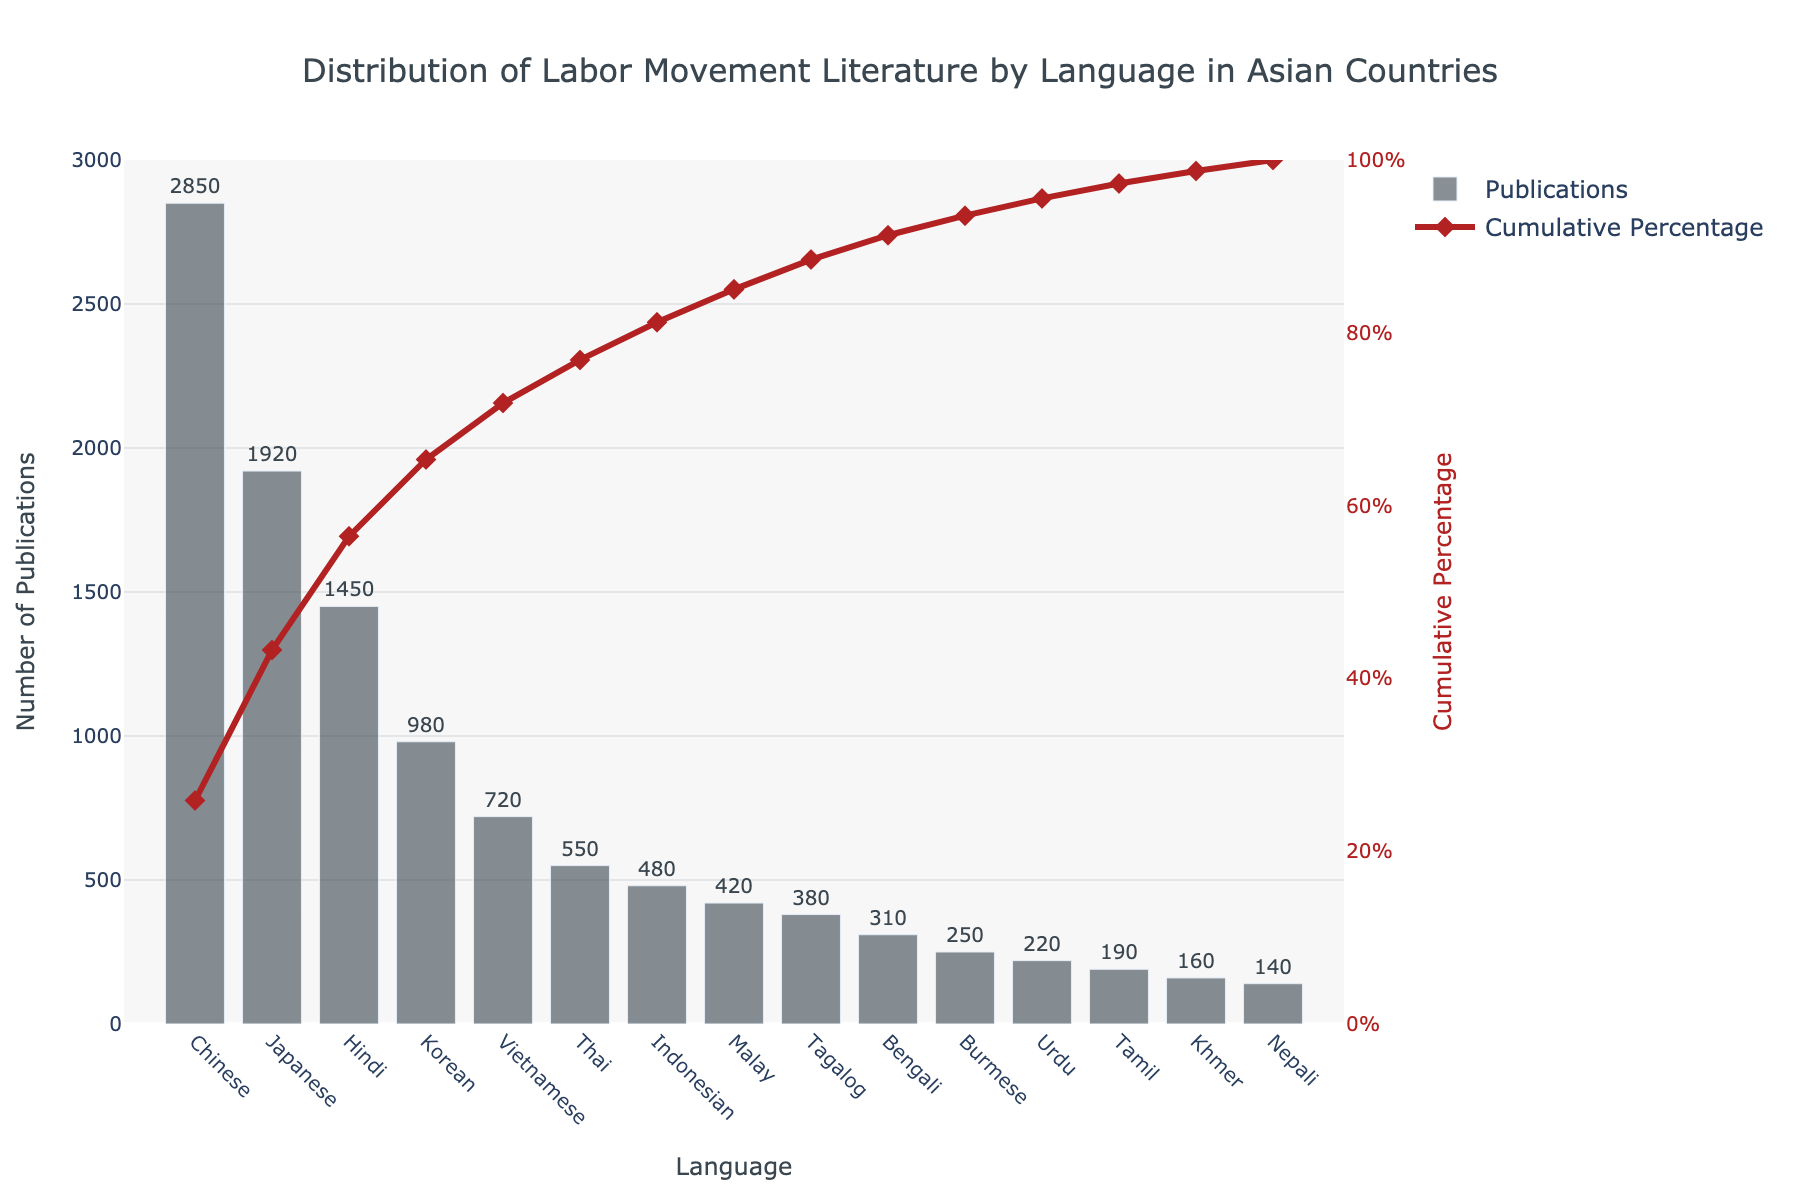What is the language with the highest number of publications? The language with the highest number of publications can be found by looking at the tallest bar in the bar chart. The tallest bar is labeled "Chinese."
Answer: Chinese What percentage of total publications do Chinese and Japanese combined contribute to? First, find the number of publications for Chinese (2850) and Japanese (1920) and add them together (2850 + 1920 = 4770). Then, find the total number of publications of all languages and divide the sum by this total. Finally, multiply by 100 to convert it to a percentage.
Answer: 48.6% Which language has the lowest number of publications? The language with the lowest number of publications is indicated by the shortest bar in the chart. The shortest bar is labeled "Nepali."
Answer: Nepali How does the cumulative percentage help in understanding the distribution of the publications? The cumulative percentage shown by the line graph helps visualize how each language's contribution adds up to the total number of publications. By looking at the points on the cumulative percentage line, we can see how quickly the majority of publications are represented. This helps in understanding the relative weight of each language's publication count in comparison to the total.
Answer: It shows the incremental contribution of each language to the total publication count Between Thai and Indonesian, which language has more publications, and by how much? From the bars representing Thai and Indonesian, Thai has 550 publications and Indonesian has 480 publications. The difference is calculated by subtracting the number of Indonesian publications from Thai publications (550 - 480).
Answer: 70 What is the cumulative percentage after adding publications in Chinese, Japanese, and Hindi? To find this, locate the cumulative percentage for each language at their corresponding points and sum them up. The cumulative percentage for Hindi directly gives the required cumulative percentage as it accumulates from previous values.
Answer: 72.4% What language ranks fifth in the number of publications? By observing the heights of the bars in descending order, the fifth highest bar corresponds to the language "Vietnamese."
Answer: Vietnamese What is the cumulative percentage for Korean? To find this, locate the point on the cumulative percentage line that corresponds to the bar for Korean publications.
Answer: 72.9% How many languages contribute to 80% of the total publications? Follow the cumulative percentage line until it reaches 80%. Count the number of languages up to this point.
Answer: 5 